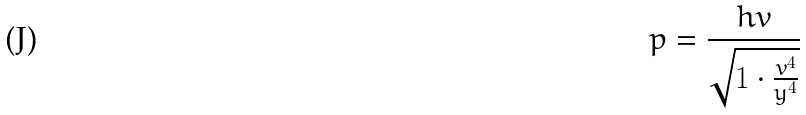Convert formula to latex. <formula><loc_0><loc_0><loc_500><loc_500>p = \frac { h v } { \sqrt { 1 \cdot \frac { v ^ { 4 } } { y ^ { 4 } } } }</formula> 